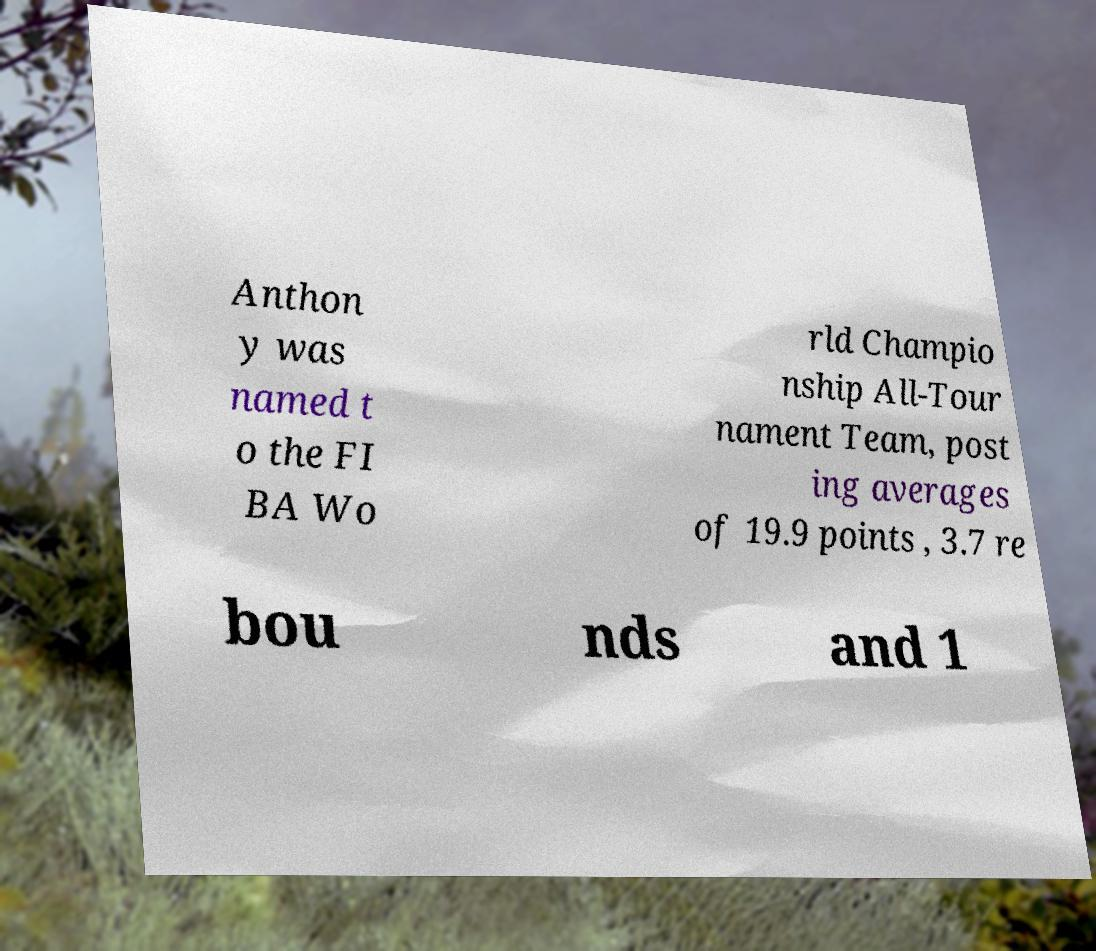For documentation purposes, I need the text within this image transcribed. Could you provide that? Anthon y was named t o the FI BA Wo rld Champio nship All-Tour nament Team, post ing averages of 19.9 points , 3.7 re bou nds and 1 